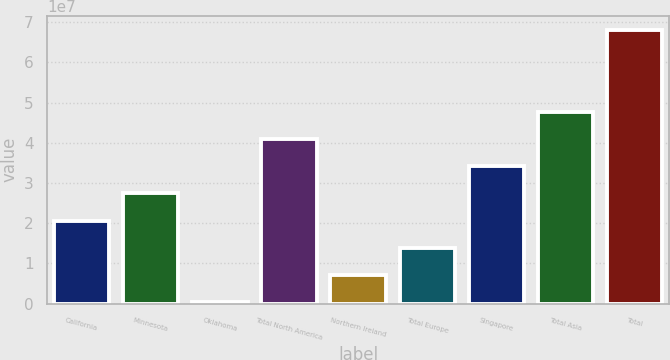<chart> <loc_0><loc_0><loc_500><loc_500><bar_chart><fcel>California<fcel>Minnesota<fcel>Oklahoma<fcel>Total North America<fcel>Northern Ireland<fcel>Total Europe<fcel>Singapore<fcel>Total Asia<fcel>Total<nl><fcel>2.06218e+07<fcel>2.74063e+07<fcel>268220<fcel>4.09753e+07<fcel>7.05274e+06<fcel>1.38373e+07<fcel>3.41908e+07<fcel>4.77599e+07<fcel>6.81134e+07<nl></chart> 